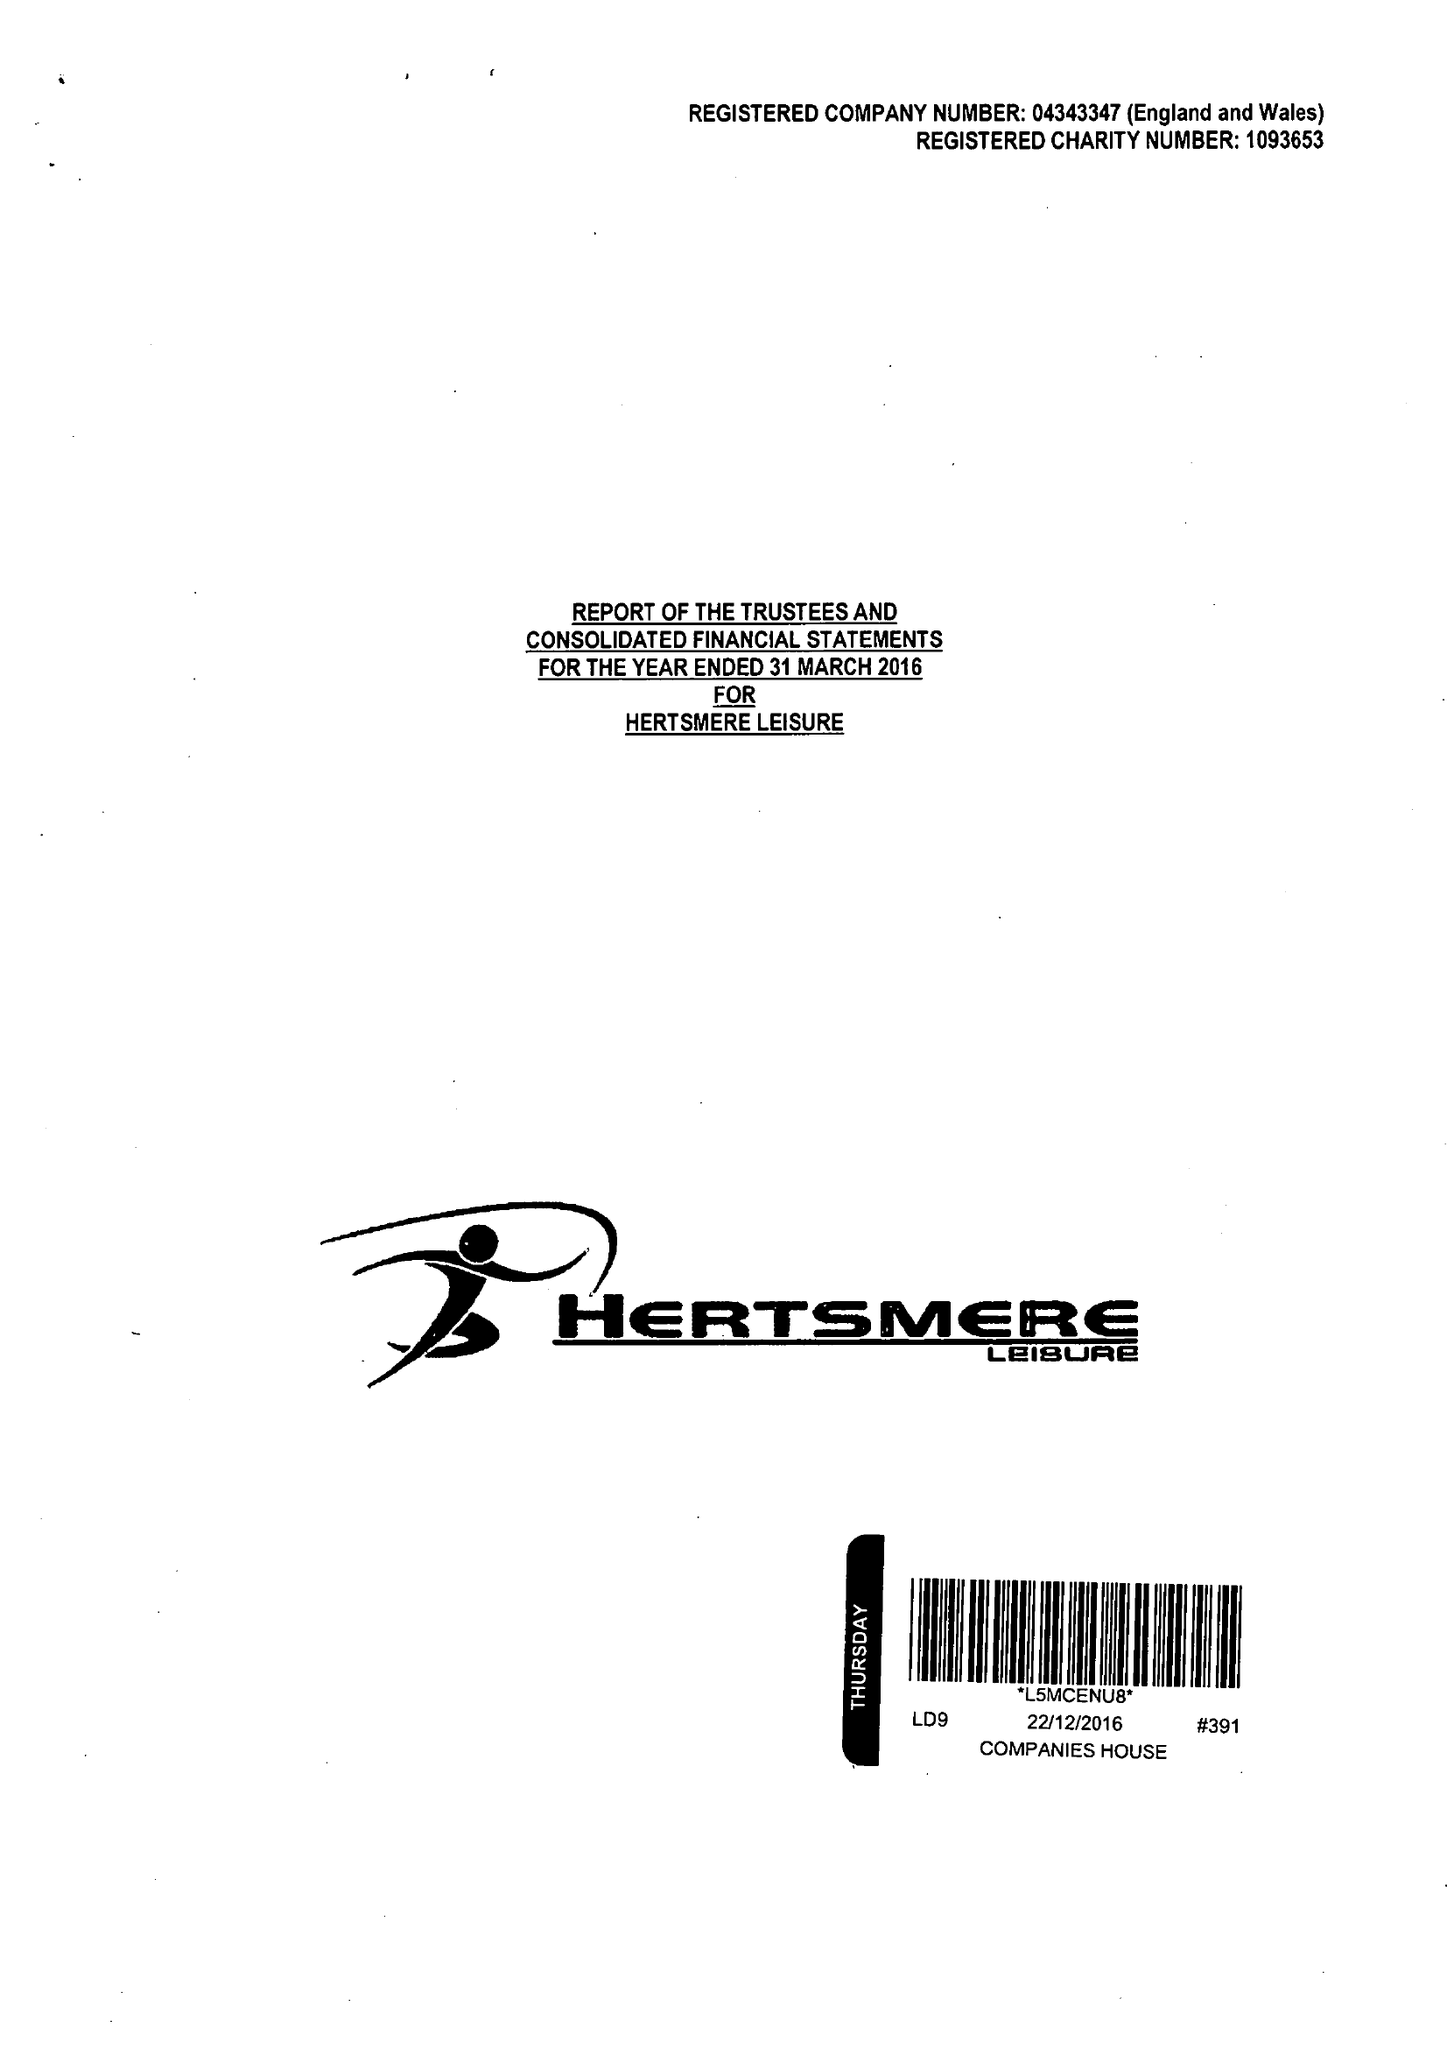What is the value for the spending_annually_in_british_pounds?
Answer the question using a single word or phrase. 19537784.00 